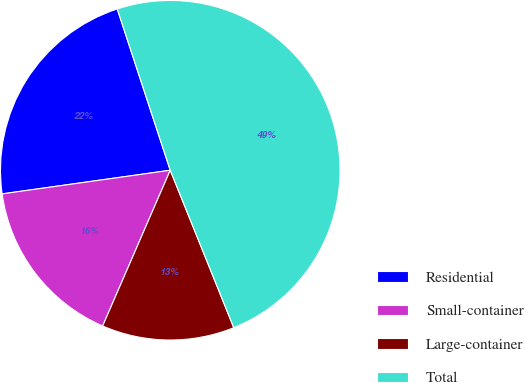Convert chart to OTSL. <chart><loc_0><loc_0><loc_500><loc_500><pie_chart><fcel>Residential<fcel>Small-container<fcel>Large-container<fcel>Total<nl><fcel>22.17%<fcel>16.26%<fcel>12.62%<fcel>48.95%<nl></chart> 